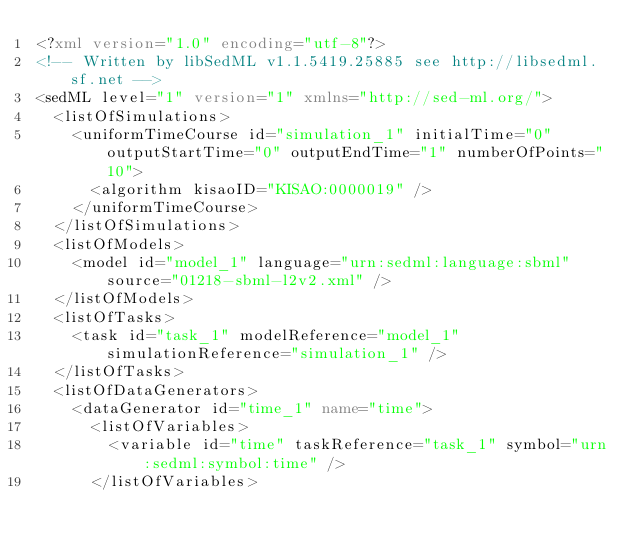Convert code to text. <code><loc_0><loc_0><loc_500><loc_500><_XML_><?xml version="1.0" encoding="utf-8"?>
<!-- Written by libSedML v1.1.5419.25885 see http://libsedml.sf.net -->
<sedML level="1" version="1" xmlns="http://sed-ml.org/">
  <listOfSimulations>
    <uniformTimeCourse id="simulation_1" initialTime="0" outputStartTime="0" outputEndTime="1" numberOfPoints="10">
      <algorithm kisaoID="KISAO:0000019" />
    </uniformTimeCourse>
  </listOfSimulations>
  <listOfModels>
    <model id="model_1" language="urn:sedml:language:sbml" source="01218-sbml-l2v2.xml" />
  </listOfModels>
  <listOfTasks>
    <task id="task_1" modelReference="model_1" simulationReference="simulation_1" />
  </listOfTasks>
  <listOfDataGenerators>
    <dataGenerator id="time_1" name="time">
      <listOfVariables>
        <variable id="time" taskReference="task_1" symbol="urn:sedml:symbol:time" />
      </listOfVariables></code> 